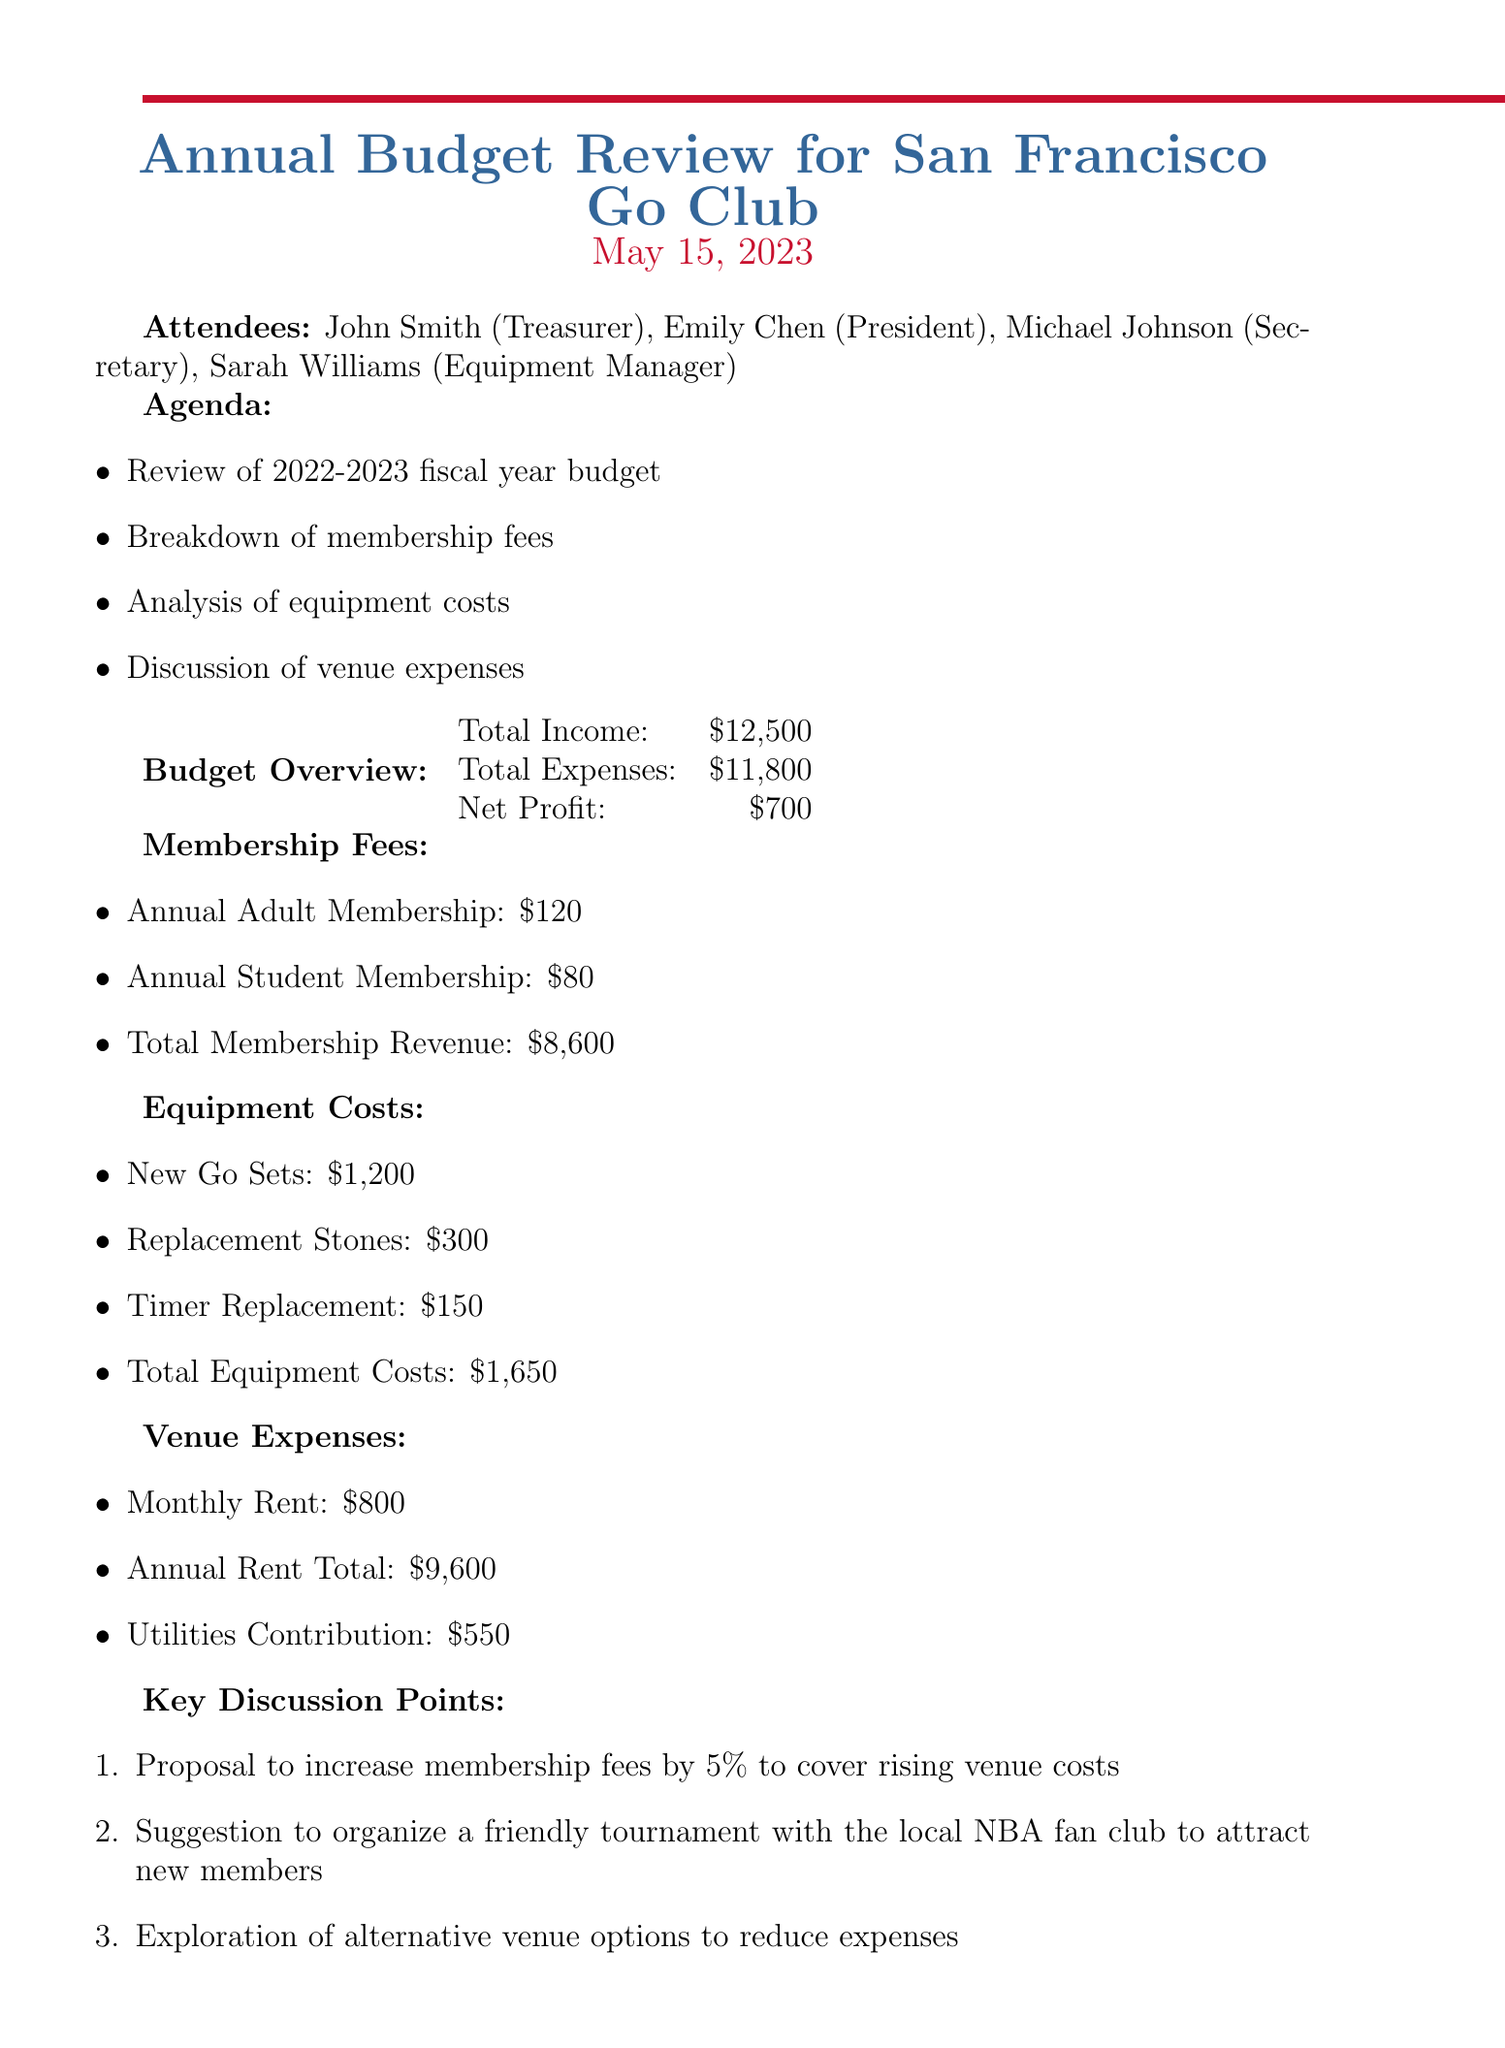what is the total income? The total income is stated in the budget overview section of the document as $12,500.
Answer: $12,500 who is the Equipment Manager? The document lists the attendees, revealing that Sarah Williams is the Equipment Manager.
Answer: Sarah Williams what is the proposal regarding membership fees? The key discussion points mention a proposal to increase membership fees by 5% to cover rising venue costs.
Answer: increase by 5% what is the total membership revenue? The document specifies the total membership revenue as $8,600 in the membership fees section.
Answer: $8,600 what are the total venue expenses? The venue expenses consist of monthly rent and utilities, adding up to annual rent of $9,600 and utilities contribution of $550, totaling $10,150.
Answer: $10,150 how many action items are listed? The document lists four specific action items that attendees need to complete, which can be counted.
Answer: 4 what is the date of the meeting? The document clearly states the date of the meeting as May 15, 2023.
Answer: May 15, 2023 what are the members planning to do with the Golden State Warriors fan club? The document notes that Michael is to reach out to the Golden State Warriors fan club for a potential joint event.
Answer: joint event what is the total equipment costs? The document provides details on equipment costs, summarizing the total as $1,650.
Answer: $1,650 